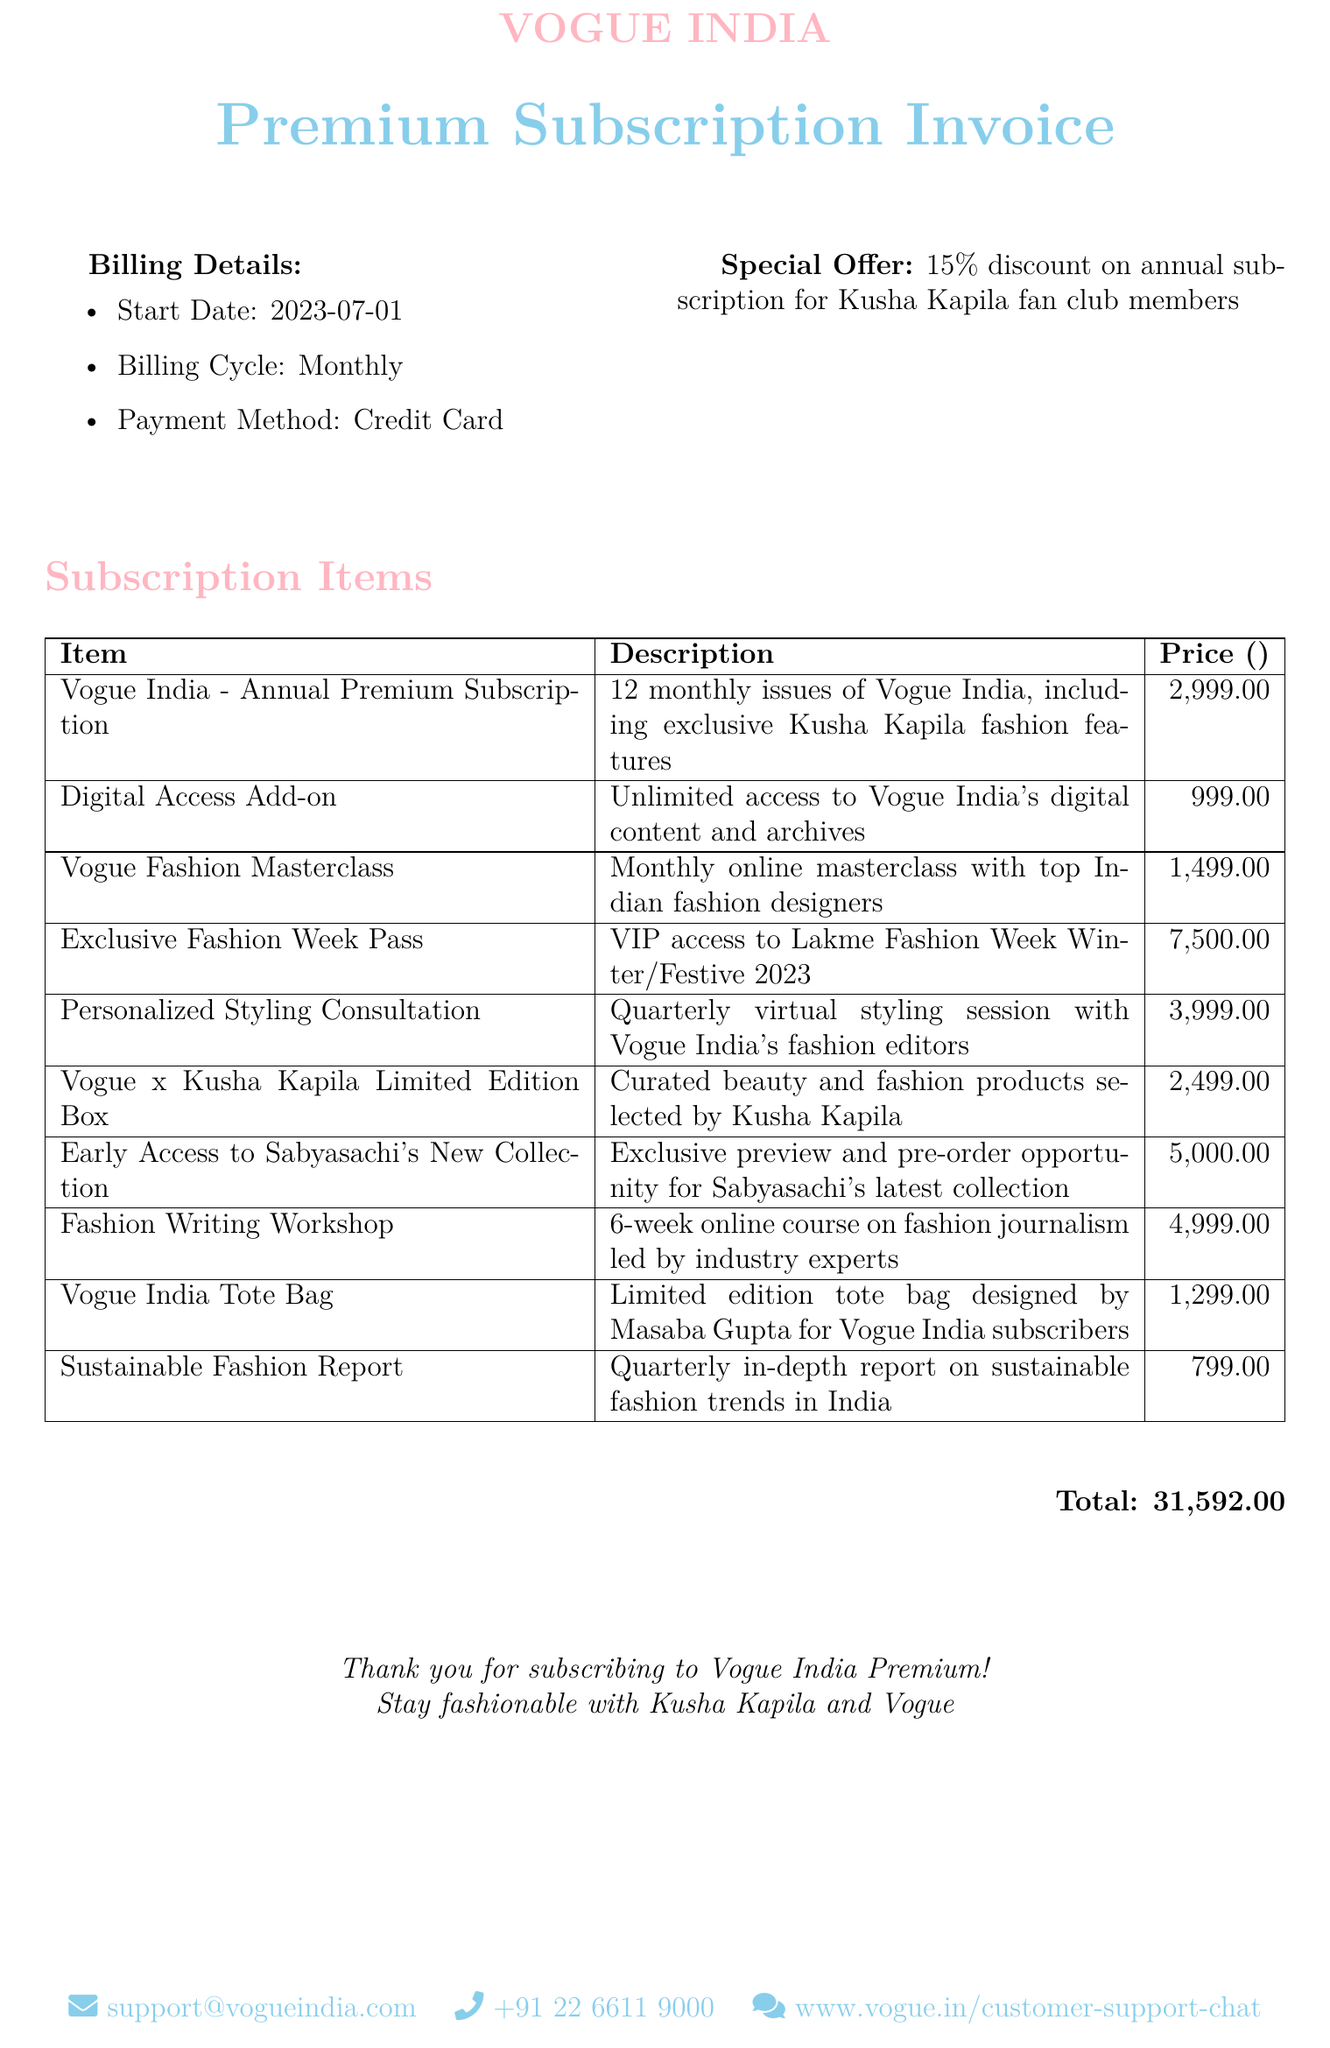What is the start date of the subscription? The start date of the subscription is mentioned in the billing details section of the document.
Answer: 2023-07-01 What is the price of the Digital Access Add-on? The price for the Digital Access Add-on can be found in the Subscription Items table.
Answer: 999.00 How many monthly issues are included in the annual premium subscription? This information is included in the description of the Vogue India - Annual Premium Subscription item.
Answer: 12 What is the total amount for all items on the invoice? The total amount is calculated at the bottom of the Subscription Items section.
Answer: ₹31,592.00 What special offer is available for Kusha Kapila fan club members? This information is included in the Billing Details section of the document.
Answer: 15% discount on annual subscription How often will the Personalized Styling Consultation occur? This detail is mentioned in the description of the Personalized Styling Consultation item.
Answer: Quarterly What is included in the Vogue x Kusha Kapila Limited Edition Box? The description under this item reveals what the box contains.
Answer: Curated beauty and fashion products selected by Kusha Kapila What type of workshop is offered in the invoice? This detail is found in the description of the Fashion Writing Workshop item.
Answer: Fashion Writing Workshop What payment method is used for billing? This information is located in the Billing Details section of the document.
Answer: Credit Card 